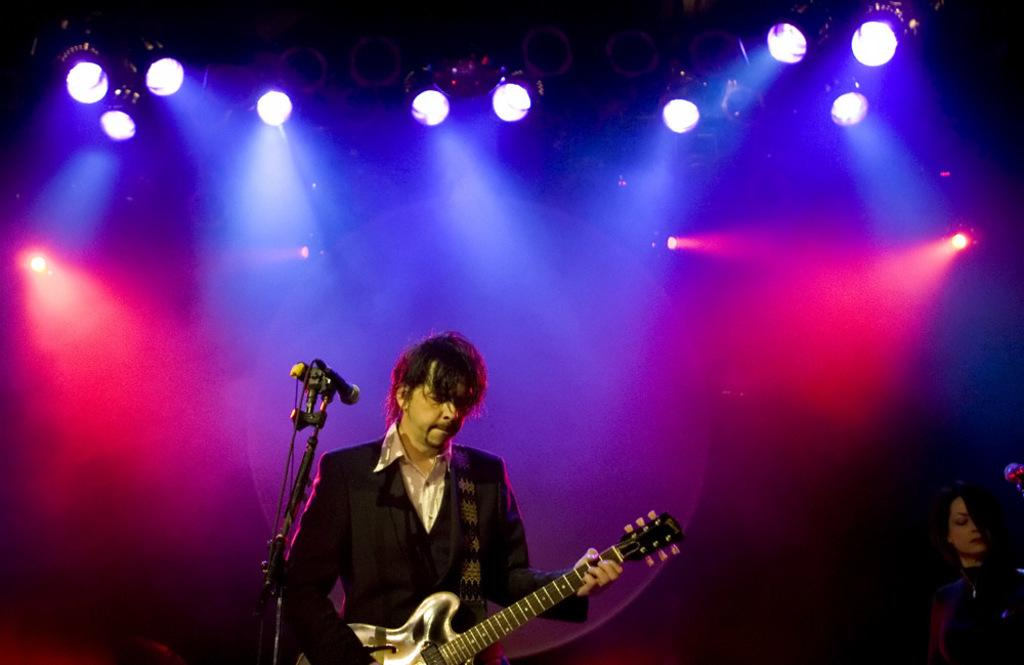What is the man in the image doing? The man is playing a guitar in the image. What type of event might be taking place in the image? The scene appears to be a concert. What can be seen in the background of the image? There are lights in the background of the image. What are the lamps used for in the image? The lamps are visible at the top of the image, possibly for illumination. How many giants are playing the drum in the image? There are no giants or drums present in the image. What type of plate is being used by the man in the image? There is no plate visible in the image; the man is playing a guitar. 